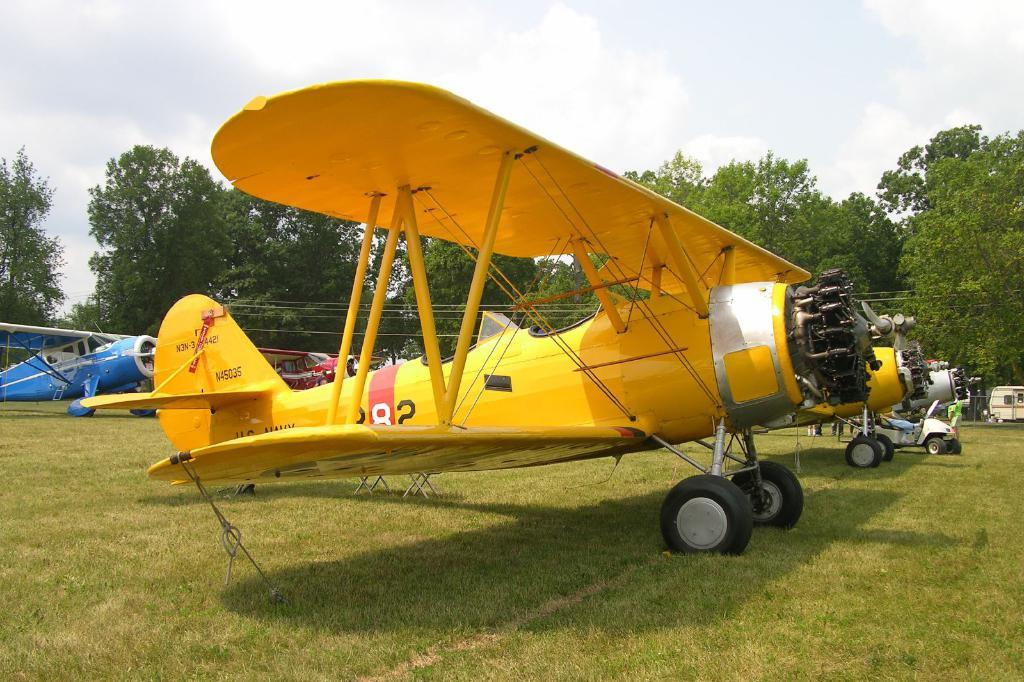<image>
Render a clear and concise summary of the photo. A yellow biplane with the tail number N45035 is parked in a field near other planes. 